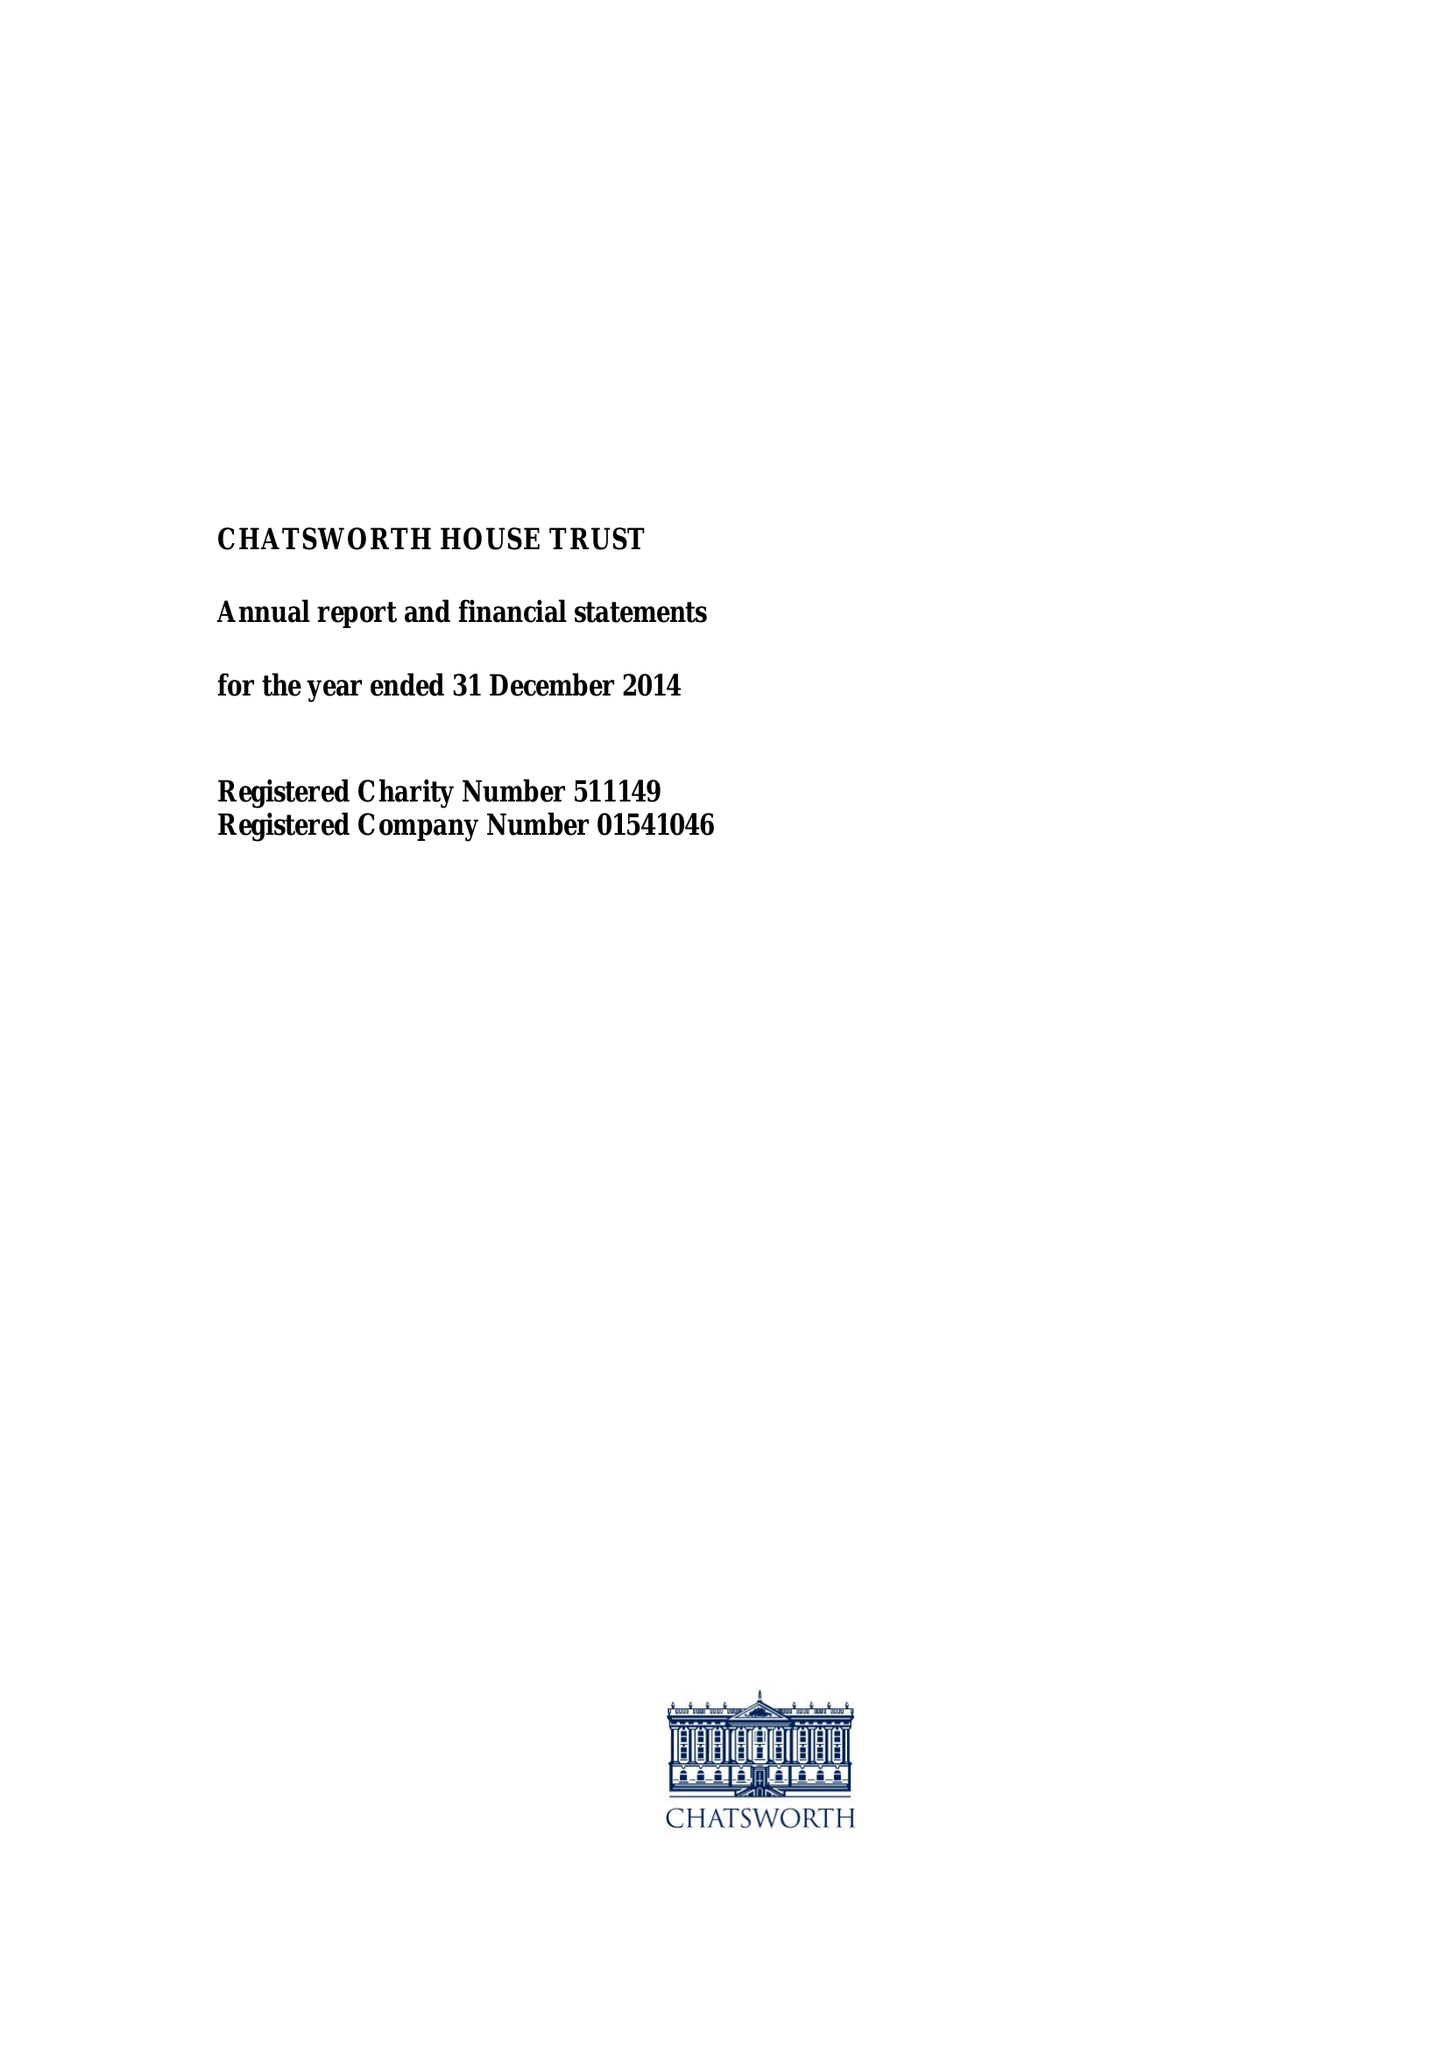What is the value for the charity_name?
Answer the question using a single word or phrase. Chatsworth House Trust 